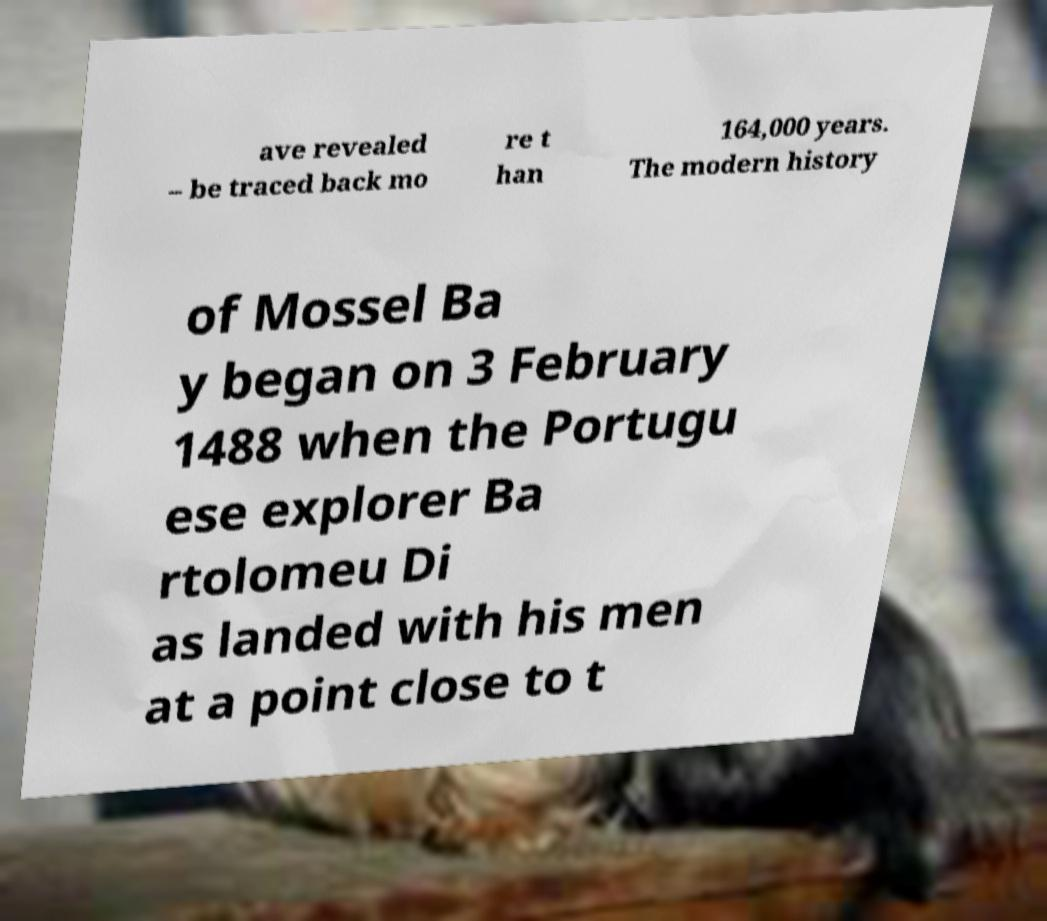There's text embedded in this image that I need extracted. Can you transcribe it verbatim? ave revealed – be traced back mo re t han 164,000 years. The modern history of Mossel Ba y began on 3 February 1488 when the Portugu ese explorer Ba rtolomeu Di as landed with his men at a point close to t 